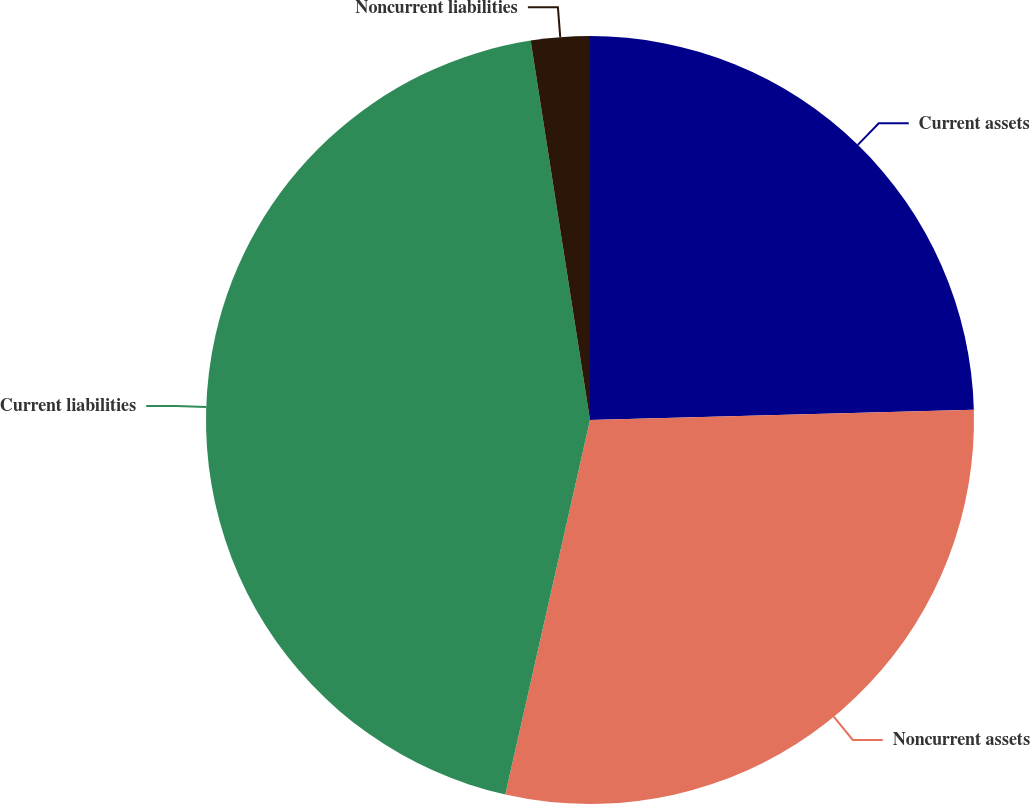Convert chart to OTSL. <chart><loc_0><loc_0><loc_500><loc_500><pie_chart><fcel>Current assets<fcel>Noncurrent assets<fcel>Current liabilities<fcel>Noncurrent liabilities<nl><fcel>24.57%<fcel>28.97%<fcel>43.99%<fcel>2.47%<nl></chart> 